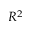Convert formula to latex. <formula><loc_0><loc_0><loc_500><loc_500>R ^ { 2 }</formula> 